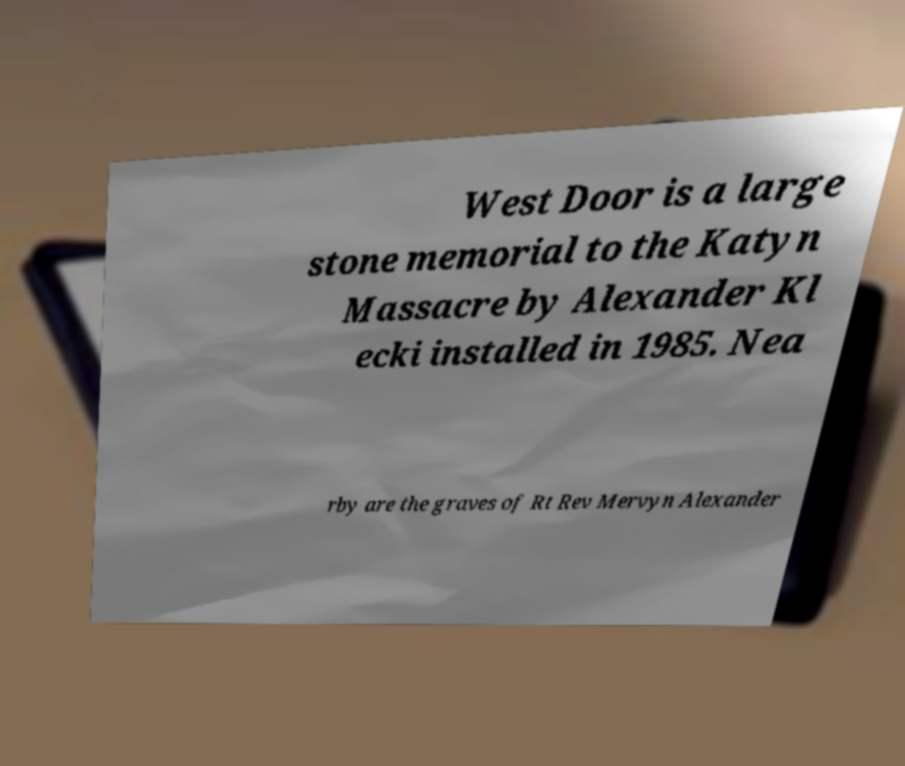Can you accurately transcribe the text from the provided image for me? West Door is a large stone memorial to the Katyn Massacre by Alexander Kl ecki installed in 1985. Nea rby are the graves of Rt Rev Mervyn Alexander 